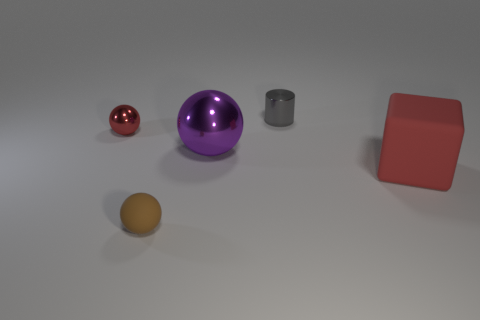Is the number of red metallic things greater than the number of small metallic things? no 